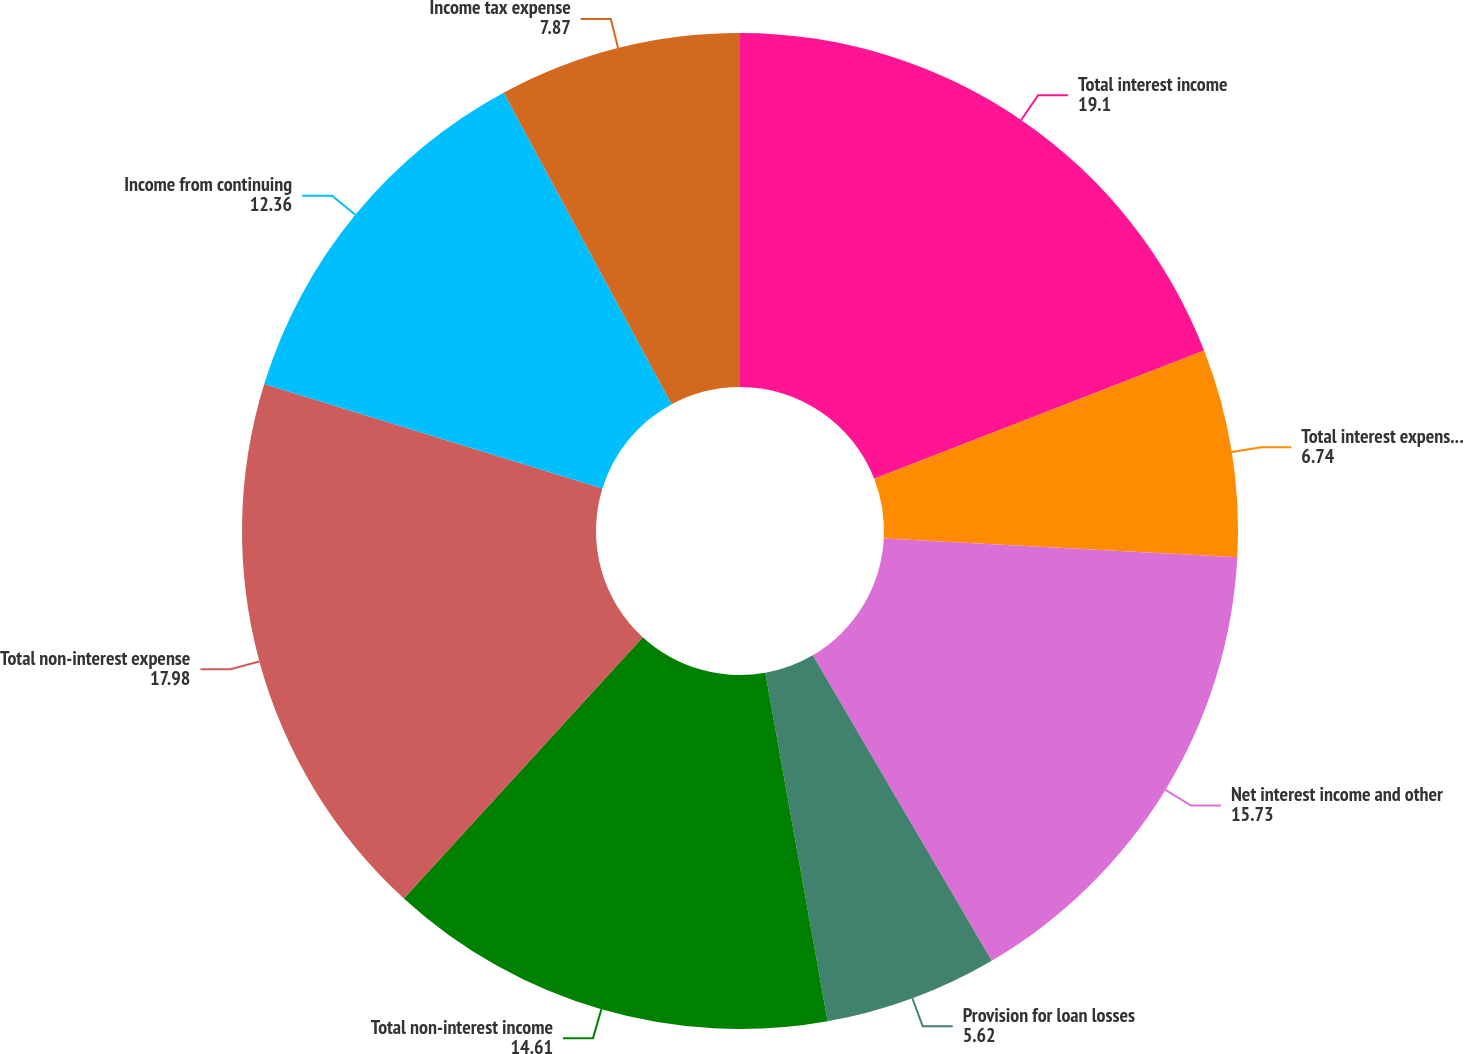<chart> <loc_0><loc_0><loc_500><loc_500><pie_chart><fcel>Total interest income<fcel>Total interest expense and<fcel>Net interest income and other<fcel>Provision for loan losses<fcel>Total non-interest income<fcel>Total non-interest expense<fcel>Income from continuing<fcel>Income tax expense<nl><fcel>19.1%<fcel>6.74%<fcel>15.73%<fcel>5.62%<fcel>14.61%<fcel>17.98%<fcel>12.36%<fcel>7.87%<nl></chart> 